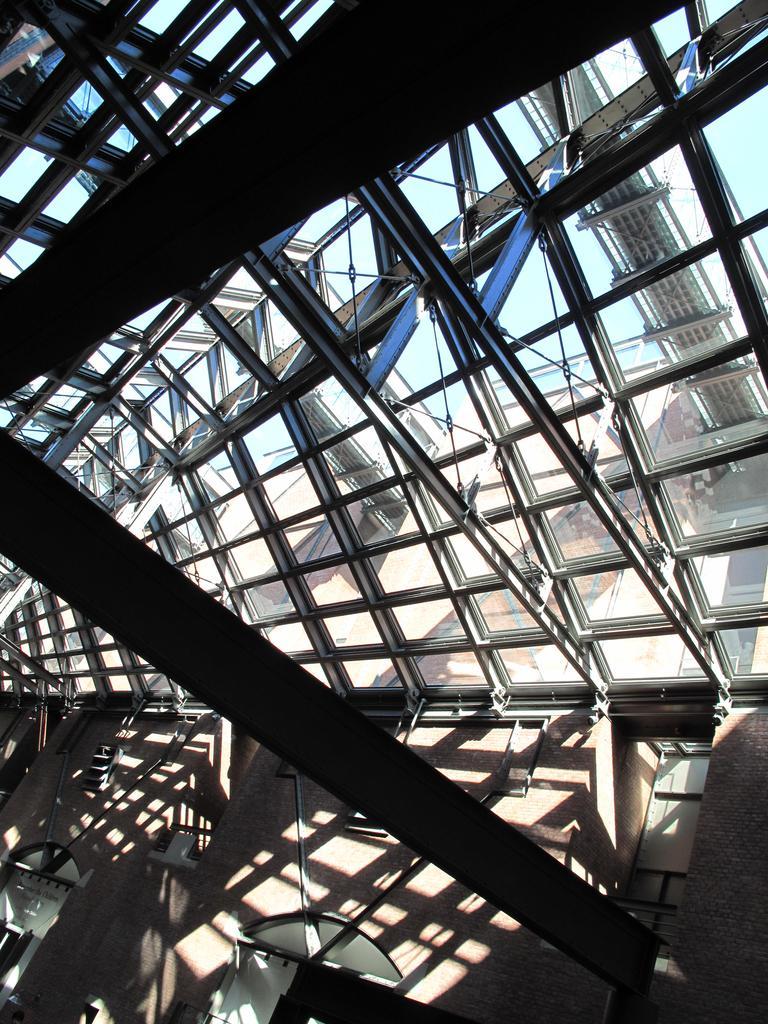How would you summarize this image in a sentence or two? In this image we can see glass roof, objects, rods and wall. Through the glass roof we can see the sky, rods and objects. 